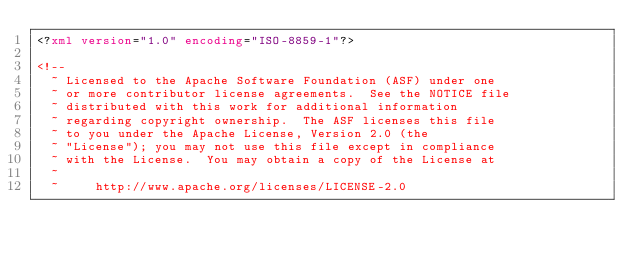Convert code to text. <code><loc_0><loc_0><loc_500><loc_500><_XML_><?xml version="1.0" encoding="ISO-8859-1"?>

<!--
  ~ Licensed to the Apache Software Foundation (ASF) under one
  ~ or more contributor license agreements.  See the NOTICE file
  ~ distributed with this work for additional information
  ~ regarding copyright ownership.  The ASF licenses this file
  ~ to you under the Apache License, Version 2.0 (the
  ~ "License"); you may not use this file except in compliance
  ~ with the License.  You may obtain a copy of the License at
  ~
  ~     http://www.apache.org/licenses/LICENSE-2.0</code> 